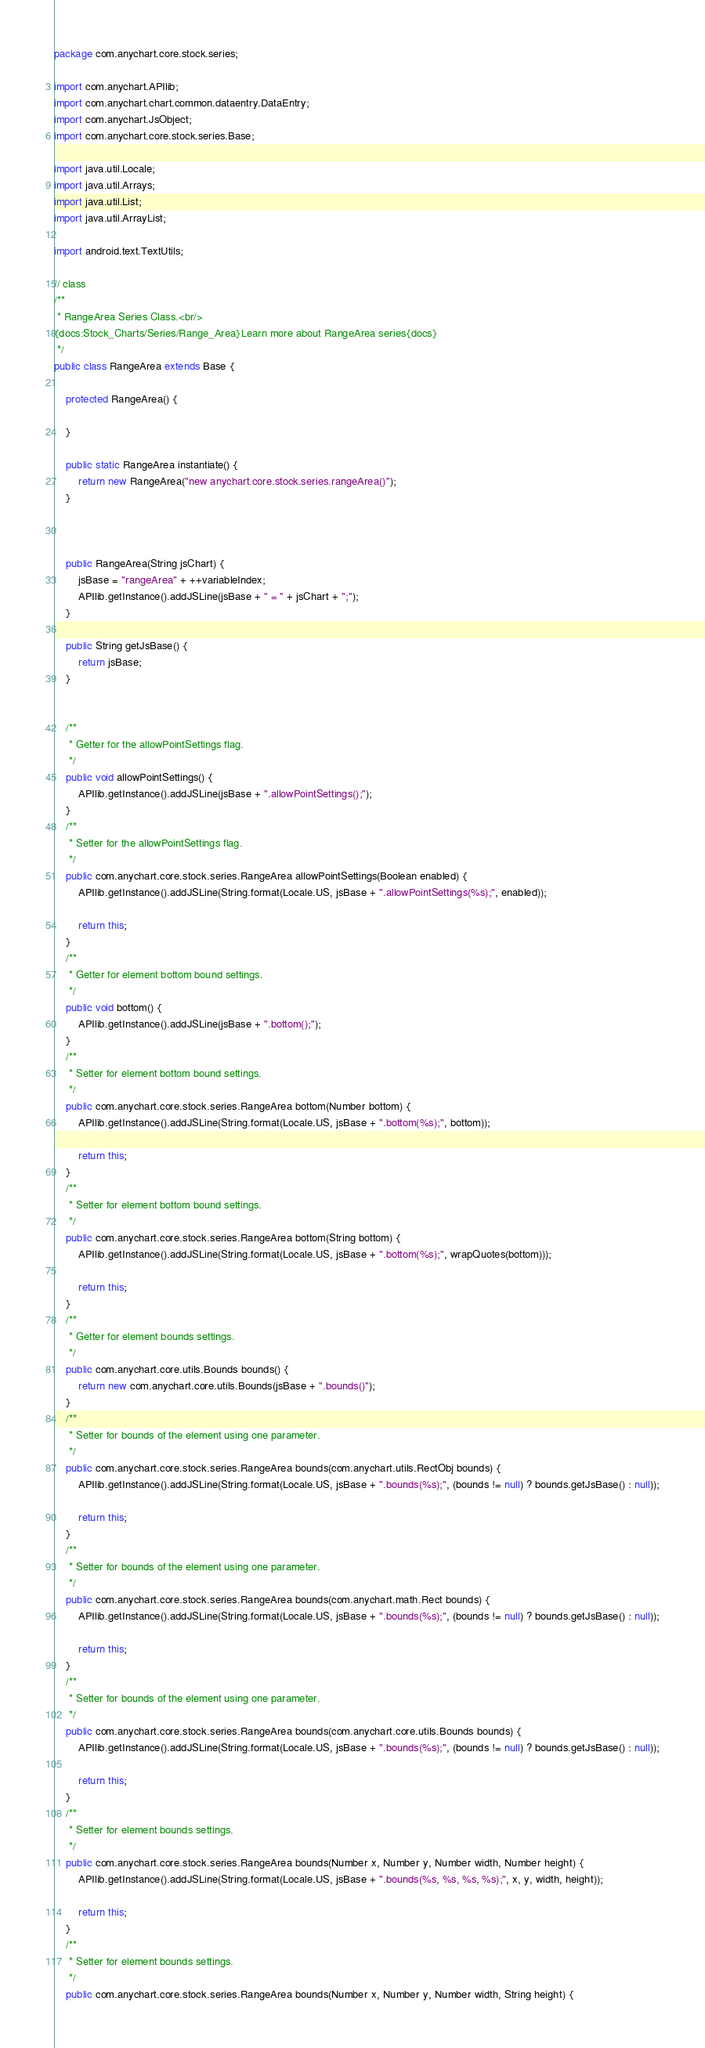Convert code to text. <code><loc_0><loc_0><loc_500><loc_500><_Java_>package com.anychart.core.stock.series;

import com.anychart.APIlib;
import com.anychart.chart.common.dataentry.DataEntry;
import com.anychart.JsObject;
import com.anychart.core.stock.series.Base;

import java.util.Locale;
import java.util.Arrays;
import java.util.List;
import java.util.ArrayList;

import android.text.TextUtils;

// class
/**
 * RangeArea Series Class.<br/>
{docs:Stock_Charts/Series/Range_Area}Learn more about RangeArea series{docs}
 */
public class RangeArea extends Base {

    protected RangeArea() {

    }

    public static RangeArea instantiate() {
        return new RangeArea("new anychart.core.stock.series.rangeArea()");
    }

    

    public RangeArea(String jsChart) {
        jsBase = "rangeArea" + ++variableIndex;
        APIlib.getInstance().addJSLine(jsBase + " = " + jsChart + ";");
    }

    public String getJsBase() {
        return jsBase;
    }

    
    /**
     * Getter for the allowPointSettings flag.
     */
    public void allowPointSettings() {
        APIlib.getInstance().addJSLine(jsBase + ".allowPointSettings();");
    }
    /**
     * Setter for the allowPointSettings flag.
     */
    public com.anychart.core.stock.series.RangeArea allowPointSettings(Boolean enabled) {
        APIlib.getInstance().addJSLine(String.format(Locale.US, jsBase + ".allowPointSettings(%s);", enabled));

        return this;
    }
    /**
     * Getter for element bottom bound settings.
     */
    public void bottom() {
        APIlib.getInstance().addJSLine(jsBase + ".bottom();");
    }
    /**
     * Setter for element bottom bound settings.
     */
    public com.anychart.core.stock.series.RangeArea bottom(Number bottom) {
        APIlib.getInstance().addJSLine(String.format(Locale.US, jsBase + ".bottom(%s);", bottom));

        return this;
    }
    /**
     * Setter for element bottom bound settings.
     */
    public com.anychart.core.stock.series.RangeArea bottom(String bottom) {
        APIlib.getInstance().addJSLine(String.format(Locale.US, jsBase + ".bottom(%s);", wrapQuotes(bottom)));

        return this;
    }
    /**
     * Getter for element bounds settings.
     */
    public com.anychart.core.utils.Bounds bounds() {
        return new com.anychart.core.utils.Bounds(jsBase + ".bounds()");
    }
    /**
     * Setter for bounds of the element using one parameter.
     */
    public com.anychart.core.stock.series.RangeArea bounds(com.anychart.utils.RectObj bounds) {
        APIlib.getInstance().addJSLine(String.format(Locale.US, jsBase + ".bounds(%s);", (bounds != null) ? bounds.getJsBase() : null));

        return this;
    }
    /**
     * Setter for bounds of the element using one parameter.
     */
    public com.anychart.core.stock.series.RangeArea bounds(com.anychart.math.Rect bounds) {
        APIlib.getInstance().addJSLine(String.format(Locale.US, jsBase + ".bounds(%s);", (bounds != null) ? bounds.getJsBase() : null));

        return this;
    }
    /**
     * Setter for bounds of the element using one parameter.
     */
    public com.anychart.core.stock.series.RangeArea bounds(com.anychart.core.utils.Bounds bounds) {
        APIlib.getInstance().addJSLine(String.format(Locale.US, jsBase + ".bounds(%s);", (bounds != null) ? bounds.getJsBase() : null));

        return this;
    }
    /**
     * Setter for element bounds settings.
     */
    public com.anychart.core.stock.series.RangeArea bounds(Number x, Number y, Number width, Number height) {
        APIlib.getInstance().addJSLine(String.format(Locale.US, jsBase + ".bounds(%s, %s, %s, %s);", x, y, width, height));

        return this;
    }
    /**
     * Setter for element bounds settings.
     */
    public com.anychart.core.stock.series.RangeArea bounds(Number x, Number y, Number width, String height) {</code> 